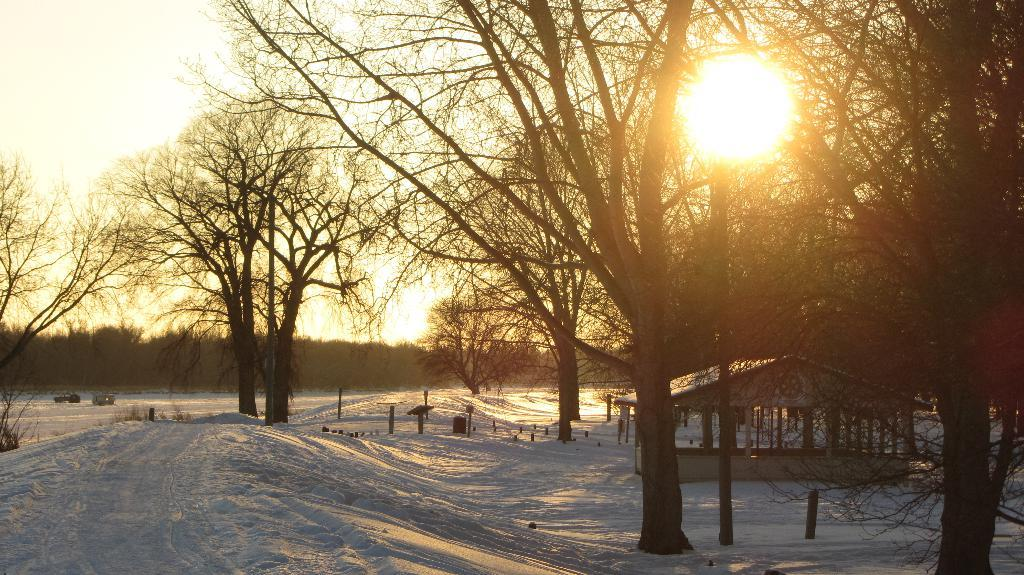What type of structure can be seen in the image? There is a shed in the image. What is the weather like in the image? There is snow visible in the image, indicating a cold or wintry environment. What type of vegetation is present in the image? There are trees in the image. What else can be seen in the image besides the shed and trees? There are poles in the image. What is visible in the background of the image? The sky is visible behind the trees in the image. What type of picture is hanging on the wall inside the shed? There is no information about a picture hanging on the wall inside the shed, as the facts provided do not mention any interior details. What scent can be detected in the image? There is no information about a scent in the image, as the facts provided do not mention any sensory details. 